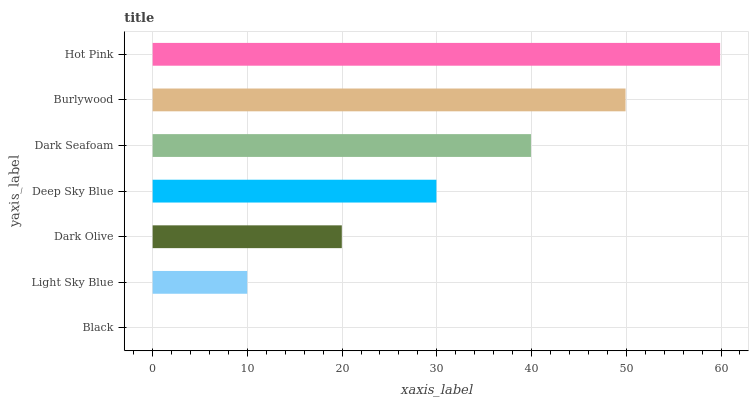Is Black the minimum?
Answer yes or no. Yes. Is Hot Pink the maximum?
Answer yes or no. Yes. Is Light Sky Blue the minimum?
Answer yes or no. No. Is Light Sky Blue the maximum?
Answer yes or no. No. Is Light Sky Blue greater than Black?
Answer yes or no. Yes. Is Black less than Light Sky Blue?
Answer yes or no. Yes. Is Black greater than Light Sky Blue?
Answer yes or no. No. Is Light Sky Blue less than Black?
Answer yes or no. No. Is Deep Sky Blue the high median?
Answer yes or no. Yes. Is Deep Sky Blue the low median?
Answer yes or no. Yes. Is Hot Pink the high median?
Answer yes or no. No. Is Light Sky Blue the low median?
Answer yes or no. No. 